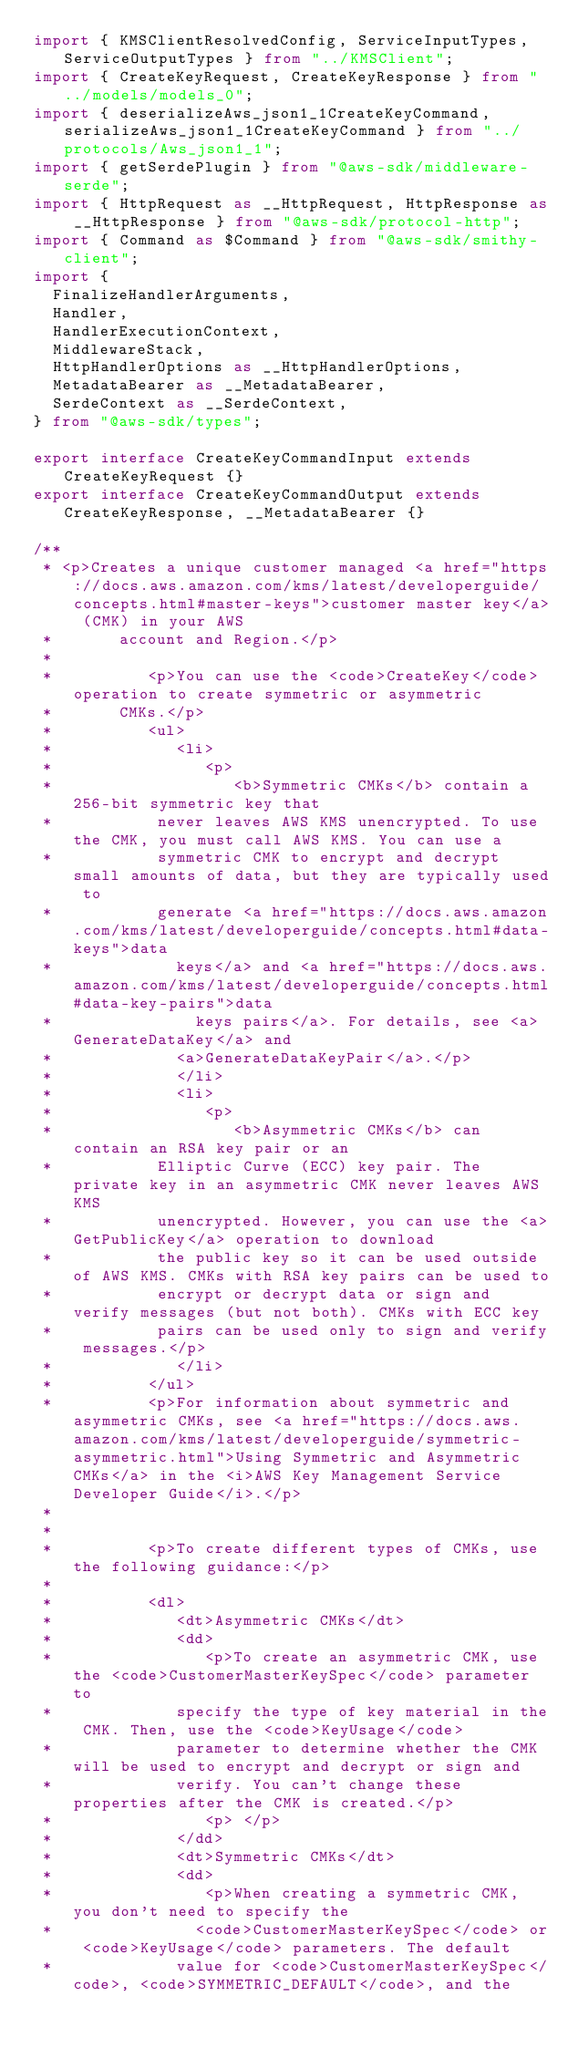<code> <loc_0><loc_0><loc_500><loc_500><_TypeScript_>import { KMSClientResolvedConfig, ServiceInputTypes, ServiceOutputTypes } from "../KMSClient";
import { CreateKeyRequest, CreateKeyResponse } from "../models/models_0";
import { deserializeAws_json1_1CreateKeyCommand, serializeAws_json1_1CreateKeyCommand } from "../protocols/Aws_json1_1";
import { getSerdePlugin } from "@aws-sdk/middleware-serde";
import { HttpRequest as __HttpRequest, HttpResponse as __HttpResponse } from "@aws-sdk/protocol-http";
import { Command as $Command } from "@aws-sdk/smithy-client";
import {
  FinalizeHandlerArguments,
  Handler,
  HandlerExecutionContext,
  MiddlewareStack,
  HttpHandlerOptions as __HttpHandlerOptions,
  MetadataBearer as __MetadataBearer,
  SerdeContext as __SerdeContext,
} from "@aws-sdk/types";

export interface CreateKeyCommandInput extends CreateKeyRequest {}
export interface CreateKeyCommandOutput extends CreateKeyResponse, __MetadataBearer {}

/**
 * <p>Creates a unique customer managed <a href="https://docs.aws.amazon.com/kms/latest/developerguide/concepts.html#master-keys">customer master key</a> (CMK) in your AWS
 *       account and Region.</p>
 *
 *          <p>You can use the <code>CreateKey</code> operation to create symmetric or asymmetric
 *       CMKs.</p>
 *          <ul>
 *             <li>
 *                <p>
 *                   <b>Symmetric CMKs</b> contain a 256-bit symmetric key that
 *           never leaves AWS KMS unencrypted. To use the CMK, you must call AWS KMS. You can use a
 *           symmetric CMK to encrypt and decrypt small amounts of data, but they are typically used to
 *           generate <a href="https://docs.aws.amazon.com/kms/latest/developerguide/concepts.html#data-keys">data
 *             keys</a> and <a href="https://docs.aws.amazon.com/kms/latest/developerguide/concepts.html#data-key-pairs">data
 *               keys pairs</a>. For details, see <a>GenerateDataKey</a> and
 *             <a>GenerateDataKeyPair</a>.</p>
 *             </li>
 *             <li>
 *                <p>
 *                   <b>Asymmetric CMKs</b> can contain an RSA key pair or an
 *           Elliptic Curve (ECC) key pair. The private key in an asymmetric CMK never leaves AWS KMS
 *           unencrypted. However, you can use the <a>GetPublicKey</a> operation to download
 *           the public key so it can be used outside of AWS KMS. CMKs with RSA key pairs can be used to
 *           encrypt or decrypt data or sign and verify messages (but not both). CMKs with ECC key
 *           pairs can be used only to sign and verify messages.</p>
 *             </li>
 *          </ul>
 *          <p>For information about symmetric and asymmetric CMKs, see <a href="https://docs.aws.amazon.com/kms/latest/developerguide/symmetric-asymmetric.html">Using Symmetric and Asymmetric CMKs</a> in the <i>AWS Key Management Service Developer Guide</i>.</p>
 *
 *
 *          <p>To create different types of CMKs, use the following guidance:</p>
 *
 *          <dl>
 *             <dt>Asymmetric CMKs</dt>
 *             <dd>
 *                <p>To create an asymmetric CMK, use the <code>CustomerMasterKeySpec</code> parameter to
 *             specify the type of key material in the CMK. Then, use the <code>KeyUsage</code>
 *             parameter to determine whether the CMK will be used to encrypt and decrypt or sign and
 *             verify. You can't change these properties after the CMK is created.</p>
 *                <p> </p>
 *             </dd>
 *             <dt>Symmetric CMKs</dt>
 *             <dd>
 *                <p>When creating a symmetric CMK, you don't need to specify the
 *               <code>CustomerMasterKeySpec</code> or <code>KeyUsage</code> parameters. The default
 *             value for <code>CustomerMasterKeySpec</code>, <code>SYMMETRIC_DEFAULT</code>, and the</code> 